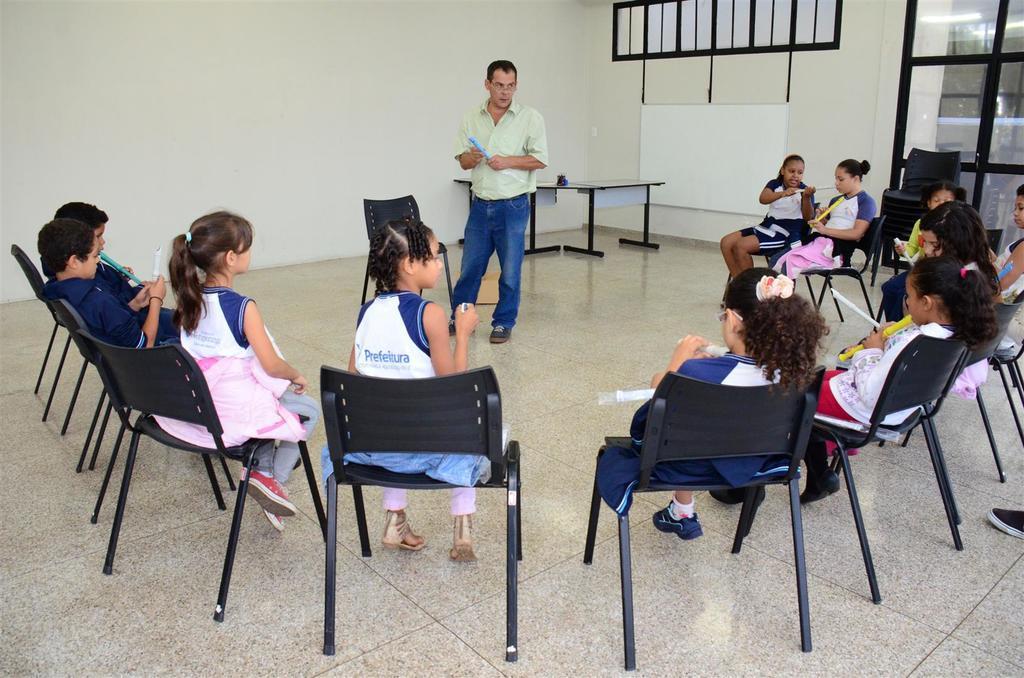Describe this image in one or two sentences. In the image we can see there are kids who are sitting on chair and in front of them there is a man who is standing and he is looking at them. 